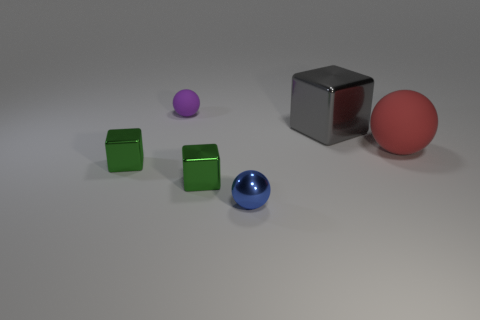How many other things are the same material as the big block?
Your answer should be very brief. 3. Do the gray metallic object and the blue shiny ball have the same size?
Provide a short and direct response. No. There is a object behind the large cube; what is its shape?
Your answer should be very brief. Sphere. There is a ball in front of the metal cube that is on the left side of the tiny purple matte ball; what is its color?
Provide a succinct answer. Blue. There is a rubber object that is to the left of the gray shiny thing; is its shape the same as the rubber object to the right of the small metal sphere?
Offer a terse response. Yes. The red thing that is the same size as the gray block is what shape?
Ensure brevity in your answer.  Sphere. There is a object that is made of the same material as the large sphere; what is its color?
Your answer should be compact. Purple. There is a purple matte thing; is its shape the same as the metal thing that is right of the blue shiny thing?
Your answer should be compact. No. What is the material of the sphere that is the same size as the blue object?
Offer a very short reply. Rubber. Are there any other big blocks that have the same color as the big block?
Your answer should be compact. No. 